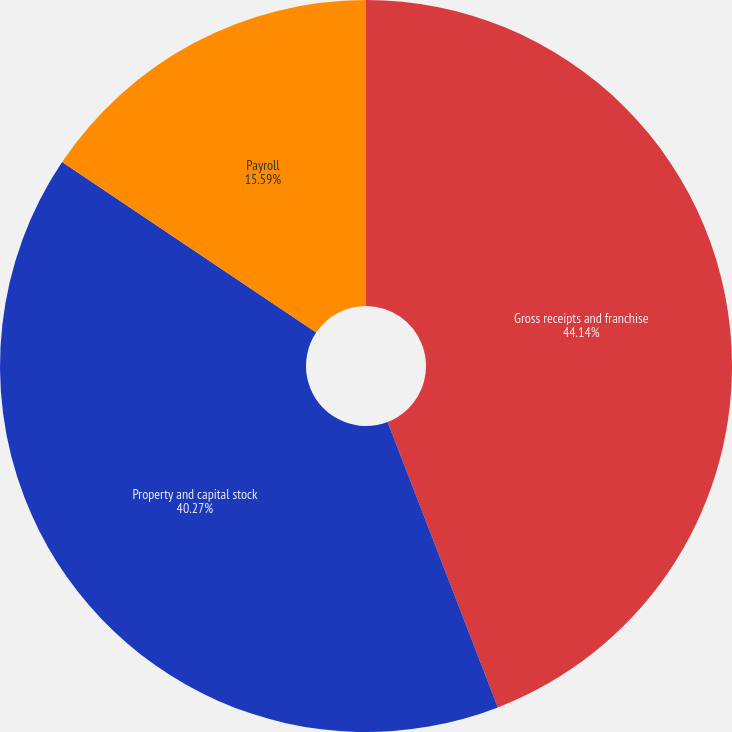<chart> <loc_0><loc_0><loc_500><loc_500><pie_chart><fcel>Gross receipts and franchise<fcel>Property and capital stock<fcel>Payroll<nl><fcel>44.13%<fcel>40.27%<fcel>15.59%<nl></chart> 